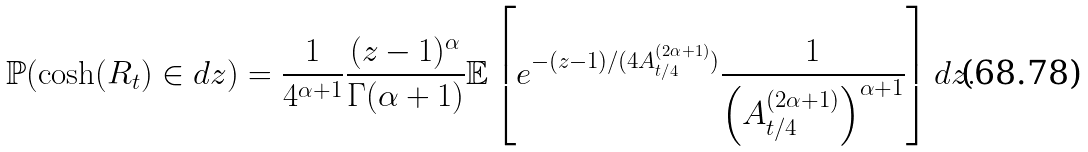Convert formula to latex. <formula><loc_0><loc_0><loc_500><loc_500>\mathbb { P } ( \cosh ( R _ { t } ) \in d z ) = \frac { 1 } { 4 ^ { \alpha + 1 } } \frac { ( z - 1 ) ^ { \alpha } } { \Gamma ( \alpha + 1 ) } \mathbb { E } \left [ e ^ { - ( z - 1 ) / ( 4 A _ { t / 4 } ^ { ( 2 \alpha + 1 ) } ) } \frac { 1 } { \left ( A _ { t / 4 } ^ { ( 2 \alpha + 1 ) } \right ) ^ { \alpha + 1 } } \right ] d z .</formula> 